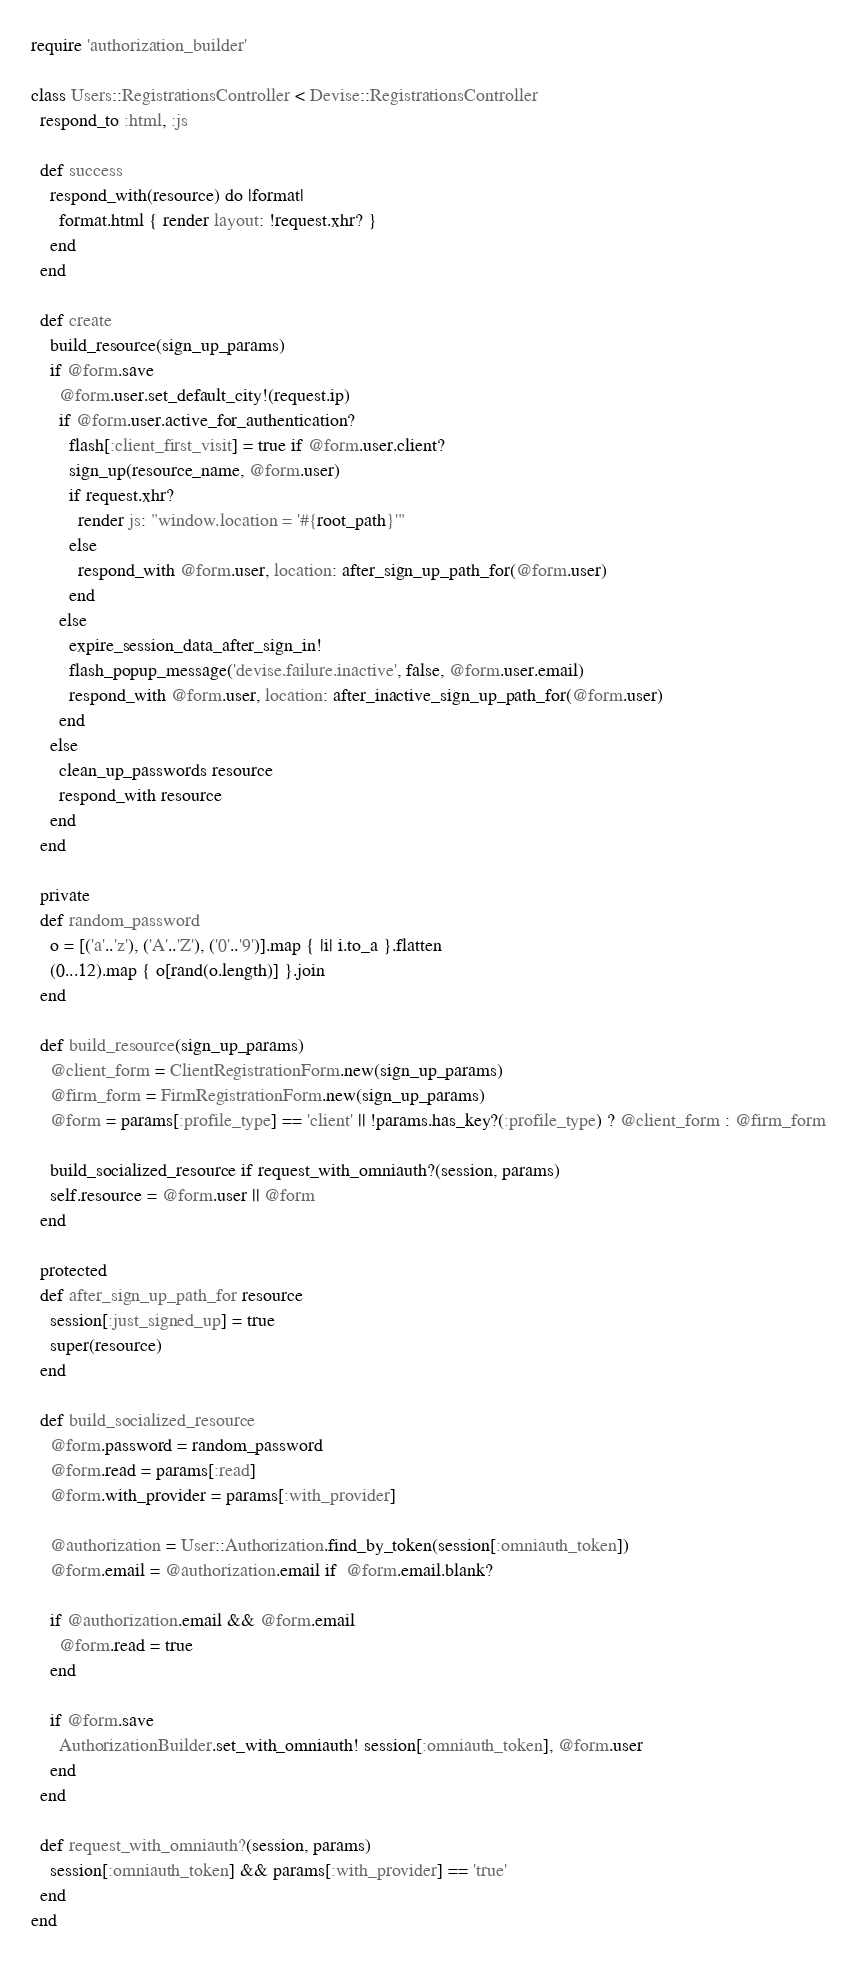Convert code to text. <code><loc_0><loc_0><loc_500><loc_500><_Ruby_>require 'authorization_builder'

class Users::RegistrationsController < Devise::RegistrationsController
  respond_to :html, :js

  def success
    respond_with(resource) do |format|
      format.html { render layout: !request.xhr? }
    end
  end

  def create
    build_resource(sign_up_params)
    if @form.save
      @form.user.set_default_city!(request.ip)
      if @form.user.active_for_authentication?
        flash[:client_first_visit] = true if @form.user.client?
        sign_up(resource_name, @form.user)
        if request.xhr?
          render js: "window.location = '#{root_path}'"
        else
          respond_with @form.user, location: after_sign_up_path_for(@form.user)
        end
      else
        expire_session_data_after_sign_in!
        flash_popup_message('devise.failure.inactive', false, @form.user.email)
        respond_with @form.user, location: after_inactive_sign_up_path_for(@form.user)
      end
    else
      clean_up_passwords resource
      respond_with resource
    end
  end

  private
  def random_password
    o = [('a'..'z'), ('A'..'Z'), ('0'..'9')].map { |i| i.to_a }.flatten
    (0...12).map { o[rand(o.length)] }.join
  end

  def build_resource(sign_up_params)
    @client_form = ClientRegistrationForm.new(sign_up_params)
    @firm_form = FirmRegistrationForm.new(sign_up_params)
    @form = params[:profile_type] == 'client' || !params.has_key?(:profile_type) ? @client_form : @firm_form

    build_socialized_resource if request_with_omniauth?(session, params)
    self.resource = @form.user || @form
  end

  protected
  def after_sign_up_path_for resource
    session[:just_signed_up] = true
    super(resource)
  end

  def build_socialized_resource
    @form.password = random_password
    @form.read = params[:read]
    @form.with_provider = params[:with_provider]

    @authorization = User::Authorization.find_by_token(session[:omniauth_token])
    @form.email = @authorization.email if  @form.email.blank?

    if @authorization.email && @form.email
      @form.read = true
    end

    if @form.save
      AuthorizationBuilder.set_with_omniauth! session[:omniauth_token], @form.user
    end
  end

  def request_with_omniauth?(session, params)
    session[:omniauth_token] && params[:with_provider] == 'true'
  end
end

</code> 